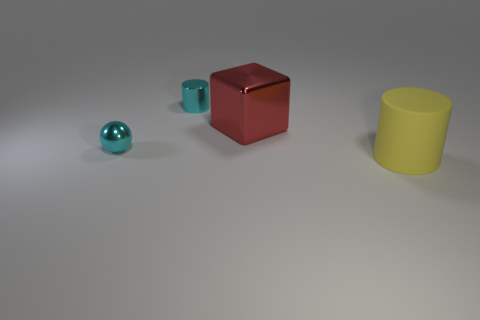There is a small ball; is its color the same as the cylinder that is left of the big yellow matte cylinder?
Your response must be concise. Yes. Does the small metallic thing that is behind the large shiny cube have the same color as the tiny shiny sphere?
Your answer should be compact. Yes. There is a metal object that is the same color as the small shiny ball; what is its shape?
Your answer should be compact. Cylinder. How many other things are the same size as the sphere?
Offer a terse response. 1. What number of things are either cyan spheres or cyan things that are on the left side of the shiny cylinder?
Provide a short and direct response. 1. Are there fewer tiny blocks than big cylinders?
Give a very brief answer. Yes. The small metallic thing that is in front of the cyan shiny object that is behind the tiny cyan ball is what color?
Provide a succinct answer. Cyan. There is a cyan thing that is the same shape as the large yellow thing; what material is it?
Make the answer very short. Metal. What number of matte things are either red blocks or yellow things?
Provide a succinct answer. 1. Do the thing that is on the left side of the metallic cylinder and the big red object that is to the right of the small metal cylinder have the same material?
Offer a terse response. Yes. 